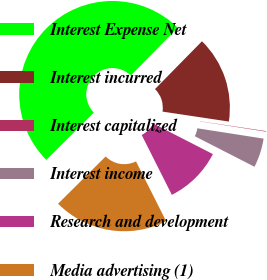Convert chart to OTSL. <chart><loc_0><loc_0><loc_500><loc_500><pie_chart><fcel>Interest Expense Net<fcel>Interest incurred<fcel>Interest capitalized<fcel>Interest income<fcel>Research and development<fcel>Media advertising (1)<nl><fcel>49.81%<fcel>15.01%<fcel>0.09%<fcel>5.07%<fcel>10.04%<fcel>19.98%<nl></chart> 